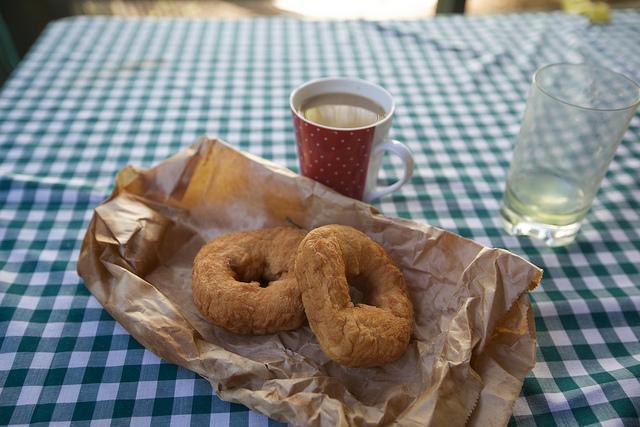What type of donuts are these?
Indicate the correct choice and explain in the format: 'Answer: answer
Rationale: rationale.'
Options: Chocolate, glazed, plain cake, powdered sugar. Answer: plain cake.
Rationale: These are just plain donuts. 